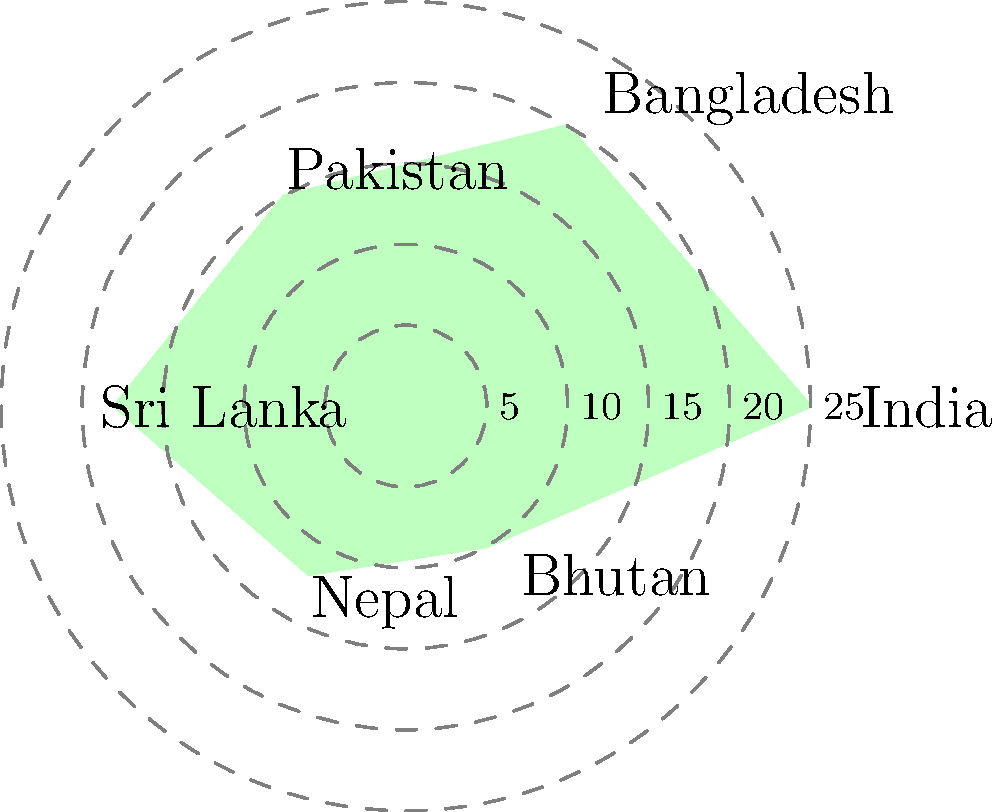In the polar area diagram representing market share distribution among South Asian countries, which country has the second-largest market share, and what is the approximate percentage difference between its share and that of India? To answer this question, we need to follow these steps:

1. Identify India's market share (the largest wedge):
   India's share is approximately 25%.

2. Identify the second-largest wedge:
   The second-largest wedge corresponds to Bangladesh, with a share of about 20%.

3. Calculate the difference:
   $$25\% - 20\% = 5\%$$

Therefore, Bangladesh has the second-largest market share, and the difference between its share and India's is approximately 5 percentage points.

This analysis demonstrates an understanding of market dynamics in South Asia, which is crucial for a business owner who has established trade networks in the region. It highlights the dominance of India in the market while also showing the significant presence of Bangladesh, which could be an important trade partner or competitor depending on the specific business context.
Answer: Bangladesh; 5% 